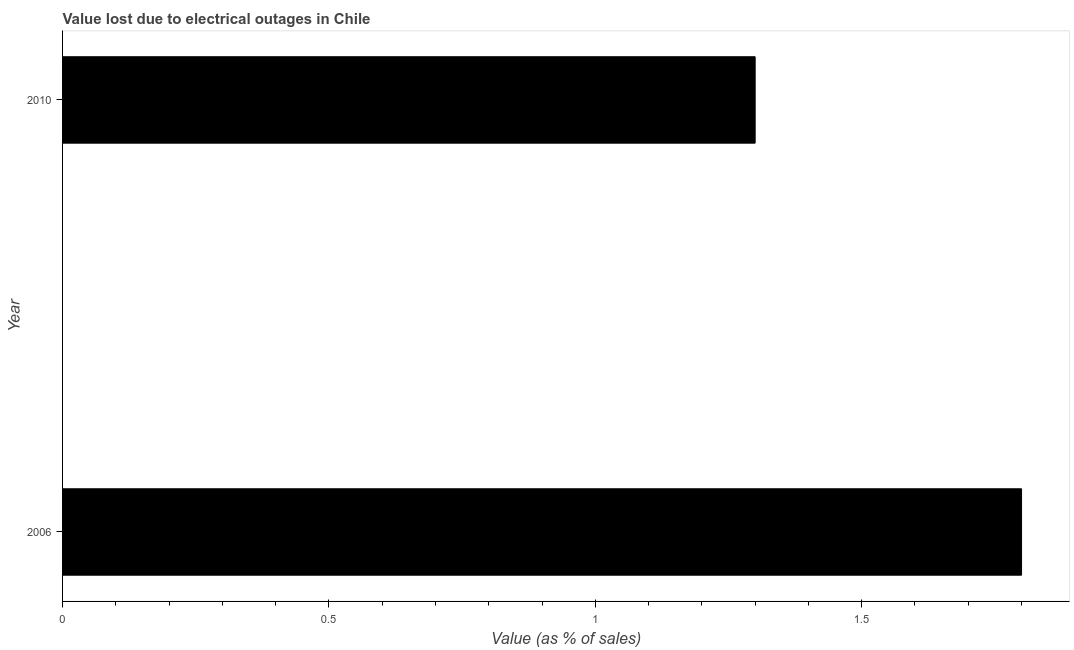Does the graph contain any zero values?
Your answer should be compact. No. Does the graph contain grids?
Offer a terse response. No. What is the title of the graph?
Your answer should be compact. Value lost due to electrical outages in Chile. What is the label or title of the X-axis?
Offer a terse response. Value (as % of sales). What is the label or title of the Y-axis?
Your response must be concise. Year. Across all years, what is the maximum value lost due to electrical outages?
Offer a terse response. 1.8. What is the difference between the value lost due to electrical outages in 2006 and 2010?
Provide a short and direct response. 0.5. What is the average value lost due to electrical outages per year?
Make the answer very short. 1.55. What is the median value lost due to electrical outages?
Offer a very short reply. 1.55. In how many years, is the value lost due to electrical outages greater than 1.4 %?
Your answer should be compact. 1. What is the ratio of the value lost due to electrical outages in 2006 to that in 2010?
Offer a very short reply. 1.39. In how many years, is the value lost due to electrical outages greater than the average value lost due to electrical outages taken over all years?
Make the answer very short. 1. Are all the bars in the graph horizontal?
Offer a terse response. Yes. What is the difference between two consecutive major ticks on the X-axis?
Your response must be concise. 0.5. Are the values on the major ticks of X-axis written in scientific E-notation?
Offer a terse response. No. What is the Value (as % of sales) of 2006?
Your response must be concise. 1.8. What is the Value (as % of sales) of 2010?
Give a very brief answer. 1.3. What is the ratio of the Value (as % of sales) in 2006 to that in 2010?
Make the answer very short. 1.39. 